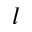<formula> <loc_0><loc_0><loc_500><loc_500>l</formula> 